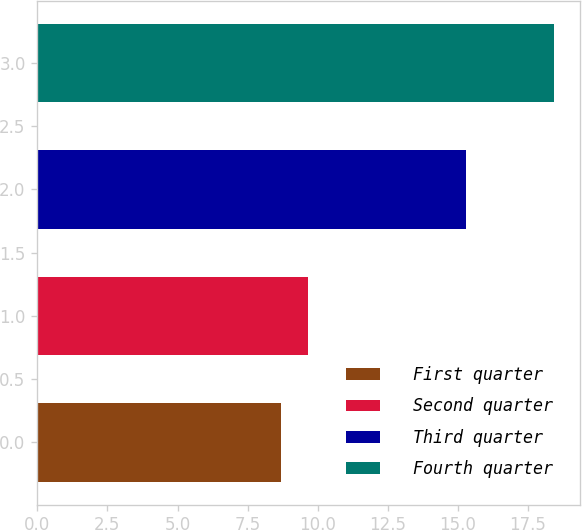<chart> <loc_0><loc_0><loc_500><loc_500><bar_chart><fcel>First quarter<fcel>Second quarter<fcel>Third quarter<fcel>Fourth quarter<nl><fcel>8.68<fcel>9.65<fcel>15.3<fcel>18.42<nl></chart> 